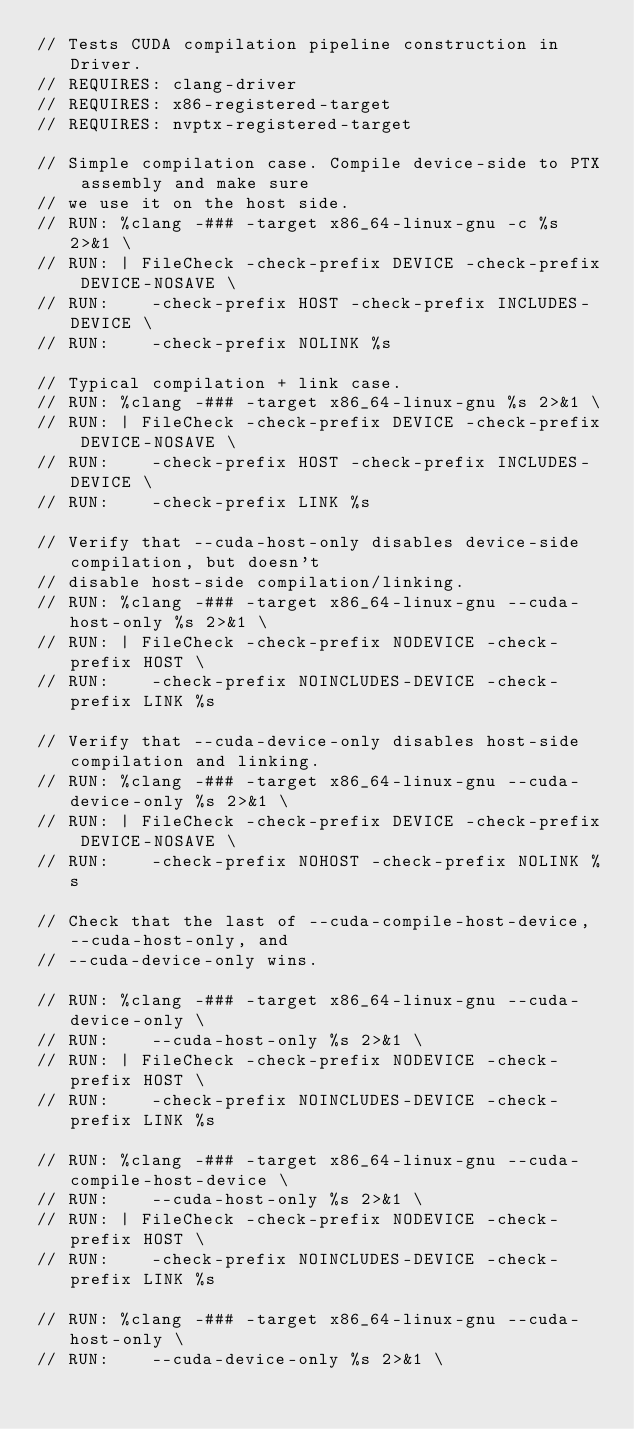<code> <loc_0><loc_0><loc_500><loc_500><_Cuda_>// Tests CUDA compilation pipeline construction in Driver.
// REQUIRES: clang-driver
// REQUIRES: x86-registered-target
// REQUIRES: nvptx-registered-target

// Simple compilation case. Compile device-side to PTX assembly and make sure
// we use it on the host side.
// RUN: %clang -### -target x86_64-linux-gnu -c %s 2>&1 \
// RUN: | FileCheck -check-prefix DEVICE -check-prefix DEVICE-NOSAVE \
// RUN:    -check-prefix HOST -check-prefix INCLUDES-DEVICE \
// RUN:    -check-prefix NOLINK %s

// Typical compilation + link case.
// RUN: %clang -### -target x86_64-linux-gnu %s 2>&1 \
// RUN: | FileCheck -check-prefix DEVICE -check-prefix DEVICE-NOSAVE \
// RUN:    -check-prefix HOST -check-prefix INCLUDES-DEVICE \
// RUN:    -check-prefix LINK %s

// Verify that --cuda-host-only disables device-side compilation, but doesn't
// disable host-side compilation/linking.
// RUN: %clang -### -target x86_64-linux-gnu --cuda-host-only %s 2>&1 \
// RUN: | FileCheck -check-prefix NODEVICE -check-prefix HOST \
// RUN:    -check-prefix NOINCLUDES-DEVICE -check-prefix LINK %s

// Verify that --cuda-device-only disables host-side compilation and linking.
// RUN: %clang -### -target x86_64-linux-gnu --cuda-device-only %s 2>&1 \
// RUN: | FileCheck -check-prefix DEVICE -check-prefix DEVICE-NOSAVE \
// RUN:    -check-prefix NOHOST -check-prefix NOLINK %s

// Check that the last of --cuda-compile-host-device, --cuda-host-only, and
// --cuda-device-only wins.

// RUN: %clang -### -target x86_64-linux-gnu --cuda-device-only \
// RUN:    --cuda-host-only %s 2>&1 \
// RUN: | FileCheck -check-prefix NODEVICE -check-prefix HOST \
// RUN:    -check-prefix NOINCLUDES-DEVICE -check-prefix LINK %s

// RUN: %clang -### -target x86_64-linux-gnu --cuda-compile-host-device \
// RUN:    --cuda-host-only %s 2>&1 \
// RUN: | FileCheck -check-prefix NODEVICE -check-prefix HOST \
// RUN:    -check-prefix NOINCLUDES-DEVICE -check-prefix LINK %s

// RUN: %clang -### -target x86_64-linux-gnu --cuda-host-only \
// RUN:    --cuda-device-only %s 2>&1 \</code> 